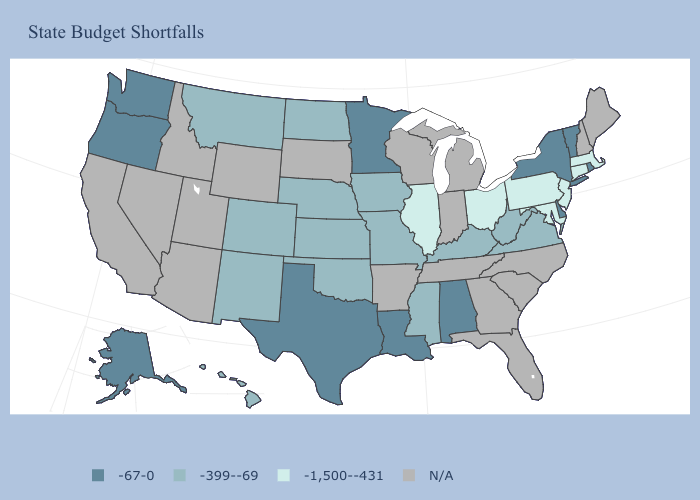What is the lowest value in states that border Rhode Island?
Be succinct. -1,500--431. Does Maryland have the lowest value in the South?
Concise answer only. Yes. Does the first symbol in the legend represent the smallest category?
Concise answer only. No. Among the states that border Nebraska , which have the lowest value?
Write a very short answer. Colorado, Iowa, Kansas, Missouri. Does the map have missing data?
Keep it brief. Yes. Is the legend a continuous bar?
Write a very short answer. No. What is the highest value in the South ?
Give a very brief answer. -67-0. Is the legend a continuous bar?
Write a very short answer. No. Name the states that have a value in the range N/A?
Write a very short answer. Arizona, Arkansas, California, Florida, Georgia, Idaho, Indiana, Maine, Michigan, Nevada, New Hampshire, North Carolina, South Carolina, South Dakota, Tennessee, Utah, Wisconsin, Wyoming. Name the states that have a value in the range -67-0?
Write a very short answer. Alabama, Alaska, Delaware, Louisiana, Minnesota, New York, Oregon, Rhode Island, Texas, Vermont, Washington. What is the value of New Jersey?
Short answer required. -1,500--431. What is the value of Iowa?
Be succinct. -399--69. Name the states that have a value in the range -67-0?
Concise answer only. Alabama, Alaska, Delaware, Louisiana, Minnesota, New York, Oregon, Rhode Island, Texas, Vermont, Washington. Which states have the highest value in the USA?
Keep it brief. Alabama, Alaska, Delaware, Louisiana, Minnesota, New York, Oregon, Rhode Island, Texas, Vermont, Washington. 